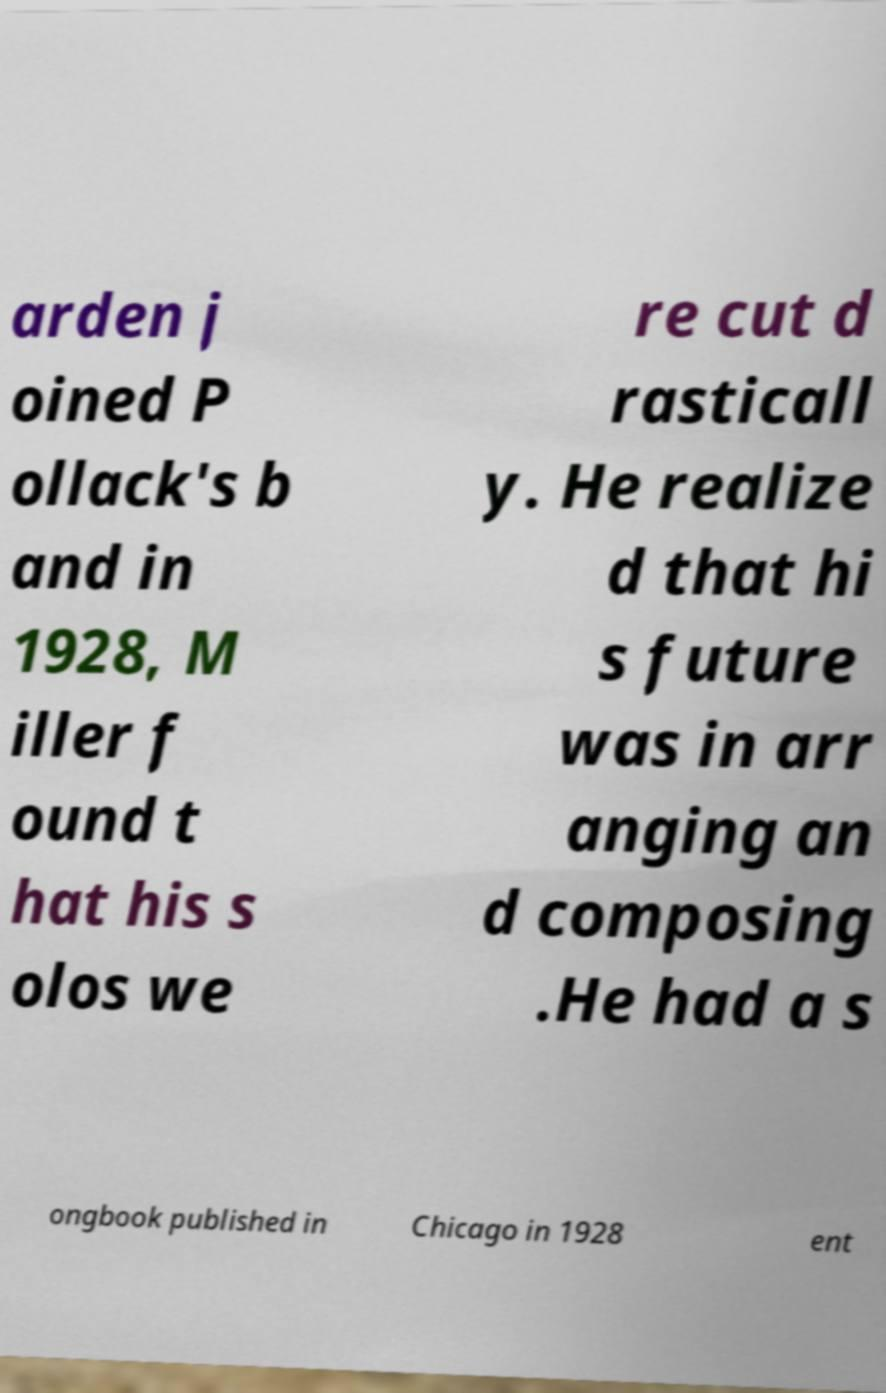Could you extract and type out the text from this image? arden j oined P ollack's b and in 1928, M iller f ound t hat his s olos we re cut d rasticall y. He realize d that hi s future was in arr anging an d composing .He had a s ongbook published in Chicago in 1928 ent 